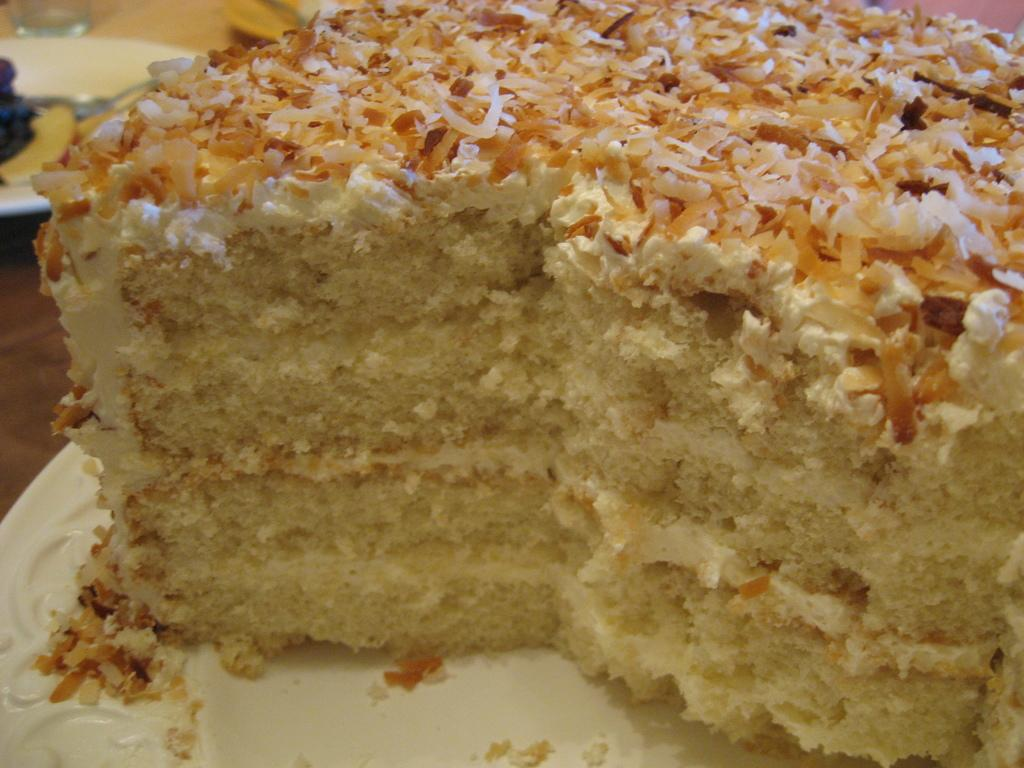What is the main food item visible in the image? There is a cake on a plate in the image. Are there any other food items visible in the image? Yes, there are other food items on plates in the background of the image. What type of container is present in the image? There is a glass in the image. What type of flower is growing on the cake in the image? There are no flowers present on the cake in the image. 